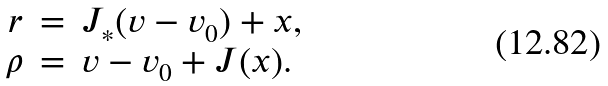<formula> <loc_0><loc_0><loc_500><loc_500>\begin{array} { r c l } r & = & J _ { * } ( v - v _ { 0 } ) + x , \\ \rho & = & v - v _ { 0 } + J ( x ) . \end{array}</formula> 